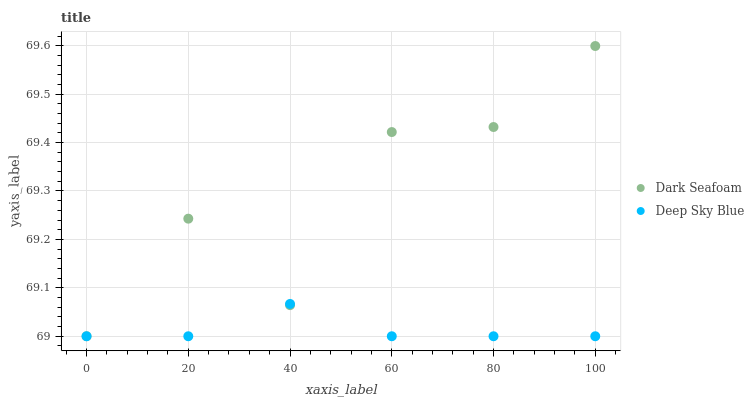Does Deep Sky Blue have the minimum area under the curve?
Answer yes or no. Yes. Does Dark Seafoam have the maximum area under the curve?
Answer yes or no. Yes. Does Deep Sky Blue have the maximum area under the curve?
Answer yes or no. No. Is Deep Sky Blue the smoothest?
Answer yes or no. Yes. Is Dark Seafoam the roughest?
Answer yes or no. Yes. Is Deep Sky Blue the roughest?
Answer yes or no. No. Does Dark Seafoam have the lowest value?
Answer yes or no. Yes. Does Dark Seafoam have the highest value?
Answer yes or no. Yes. Does Deep Sky Blue have the highest value?
Answer yes or no. No. Does Dark Seafoam intersect Deep Sky Blue?
Answer yes or no. Yes. Is Dark Seafoam less than Deep Sky Blue?
Answer yes or no. No. Is Dark Seafoam greater than Deep Sky Blue?
Answer yes or no. No. 